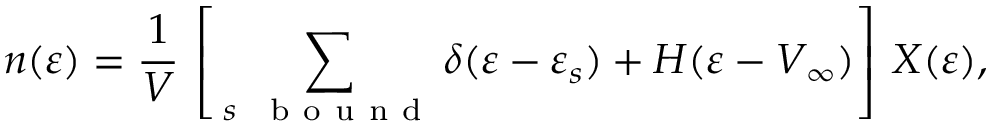Convert formula to latex. <formula><loc_0><loc_0><loc_500><loc_500>n ( \varepsilon ) = \frac { 1 } { V } \, \left [ \, \sum _ { s \, b o u n d } \delta ( \varepsilon - \varepsilon _ { s } ) + H ( \varepsilon - V _ { \infty } ) \right ] \, X ( \varepsilon ) ,</formula> 